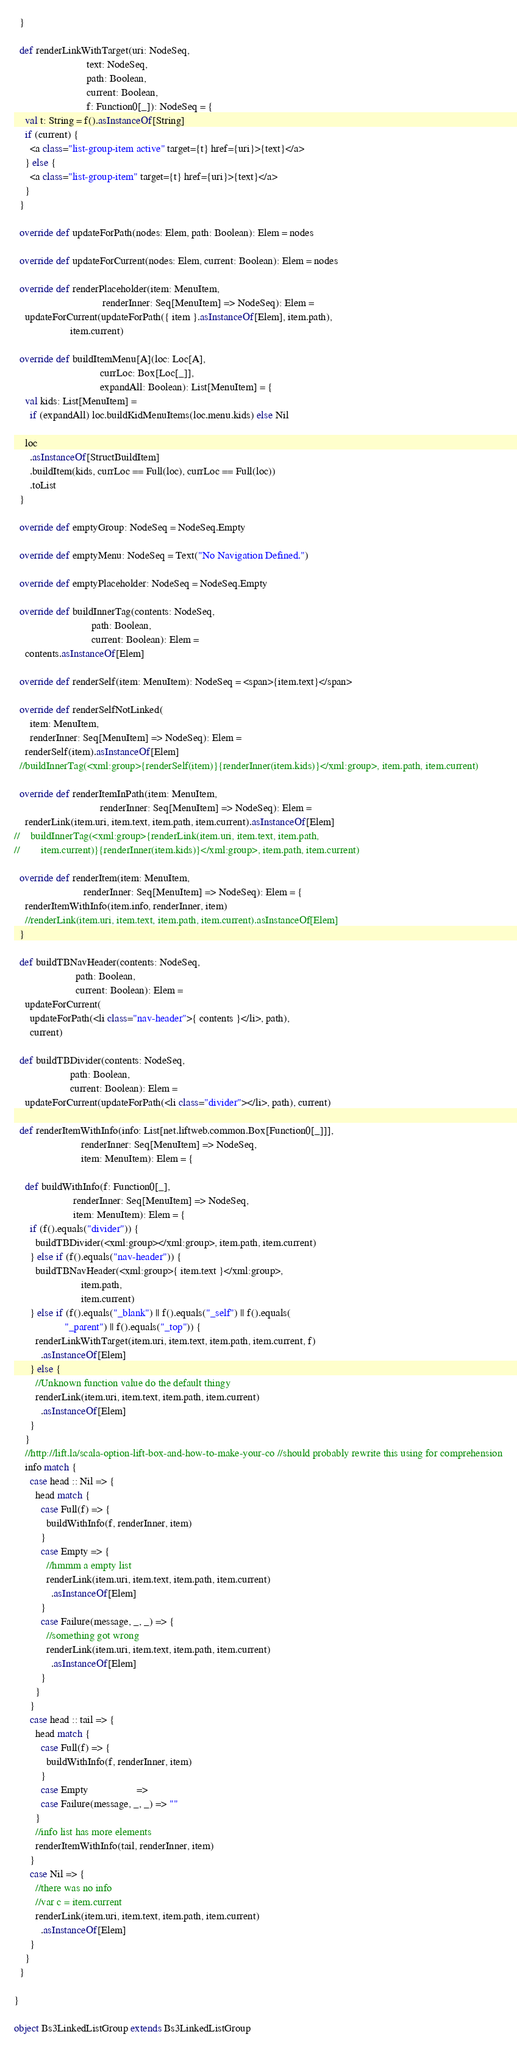<code> <loc_0><loc_0><loc_500><loc_500><_Scala_>  }

  def renderLinkWithTarget(uri: NodeSeq,
                           text: NodeSeq,
                           path: Boolean,
                           current: Boolean,
                           f: Function0[_]): NodeSeq = {
    val t: String = f().asInstanceOf[String]
    if (current) {
      <a class="list-group-item active" target={t} href={uri}>{text}</a>
    } else {
      <a class="list-group-item" target={t} href={uri}>{text}</a>
    }
  }

  override def updateForPath(nodes: Elem, path: Boolean): Elem = nodes

  override def updateForCurrent(nodes: Elem, current: Boolean): Elem = nodes

  override def renderPlaceholder(item: MenuItem,
                                 renderInner: Seq[MenuItem] => NodeSeq): Elem =
    updateForCurrent(updateForPath({ item }.asInstanceOf[Elem], item.path),
                     item.current)

  override def buildItemMenu[A](loc: Loc[A],
                                currLoc: Box[Loc[_]],
                                expandAll: Boolean): List[MenuItem] = {
    val kids: List[MenuItem] =
      if (expandAll) loc.buildKidMenuItems(loc.menu.kids) else Nil

    loc
      .asInstanceOf[StructBuildItem]
      .buildItem(kids, currLoc == Full(loc), currLoc == Full(loc))
      .toList
  }

  override def emptyGroup: NodeSeq = NodeSeq.Empty

  override def emptyMenu: NodeSeq = Text("No Navigation Defined.")

  override def emptyPlaceholder: NodeSeq = NodeSeq.Empty

  override def buildInnerTag(contents: NodeSeq,
                             path: Boolean,
                             current: Boolean): Elem =
    contents.asInstanceOf[Elem]

  override def renderSelf(item: MenuItem): NodeSeq = <span>{item.text}</span>

  override def renderSelfNotLinked(
      item: MenuItem,
      renderInner: Seq[MenuItem] => NodeSeq): Elem =
    renderSelf(item).asInstanceOf[Elem]
  //buildInnerTag(<xml:group>{renderSelf(item)}{renderInner(item.kids)}</xml:group>, item.path, item.current)

  override def renderItemInPath(item: MenuItem,
                                renderInner: Seq[MenuItem] => NodeSeq): Elem =
    renderLink(item.uri, item.text, item.path, item.current).asInstanceOf[Elem]
//    buildInnerTag(<xml:group>{renderLink(item.uri, item.text, item.path,
//        item.current)}{renderInner(item.kids)}</xml:group>, item.path, item.current)

  override def renderItem(item: MenuItem,
                          renderInner: Seq[MenuItem] => NodeSeq): Elem = {
    renderItemWithInfo(item.info, renderInner, item)
    //renderLink(item.uri, item.text, item.path, item.current).asInstanceOf[Elem]
  }

  def buildTBNavHeader(contents: NodeSeq,
                       path: Boolean,
                       current: Boolean): Elem =
    updateForCurrent(
      updateForPath(<li class="nav-header">{ contents }</li>, path),
      current)

  def buildTBDivider(contents: NodeSeq,
                     path: Boolean,
                     current: Boolean): Elem =
    updateForCurrent(updateForPath(<li class="divider"></li>, path), current)

  def renderItemWithInfo(info: List[net.liftweb.common.Box[Function0[_]]],
                         renderInner: Seq[MenuItem] => NodeSeq,
                         item: MenuItem): Elem = {

    def buildWithInfo(f: Function0[_],
                      renderInner: Seq[MenuItem] => NodeSeq,
                      item: MenuItem): Elem = {
      if (f().equals("divider")) {
        buildTBDivider(<xml:group></xml:group>, item.path, item.current)
      } else if (f().equals("nav-header")) {
        buildTBNavHeader(<xml:group>{ item.text }</xml:group>,
                         item.path,
                         item.current)
      } else if (f().equals("_blank") || f().equals("_self") || f().equals(
                   "_parent") || f().equals("_top")) {
        renderLinkWithTarget(item.uri, item.text, item.path, item.current, f)
          .asInstanceOf[Elem]
      } else {
        //Unknown function value do the default thingy
        renderLink(item.uri, item.text, item.path, item.current)
          .asInstanceOf[Elem]
      }
    }
    //http://lift.la/scala-option-lift-box-and-how-to-make-your-co //should probably rewrite this using for comprehension
    info match {
      case head :: Nil => {
        head match {
          case Full(f) => {
            buildWithInfo(f, renderInner, item)
          }
          case Empty => {
            //hmmm a empty list
            renderLink(item.uri, item.text, item.path, item.current)
              .asInstanceOf[Elem]
          }
          case Failure(message, _, _) => {
            //something got wrong
            renderLink(item.uri, item.text, item.path, item.current)
              .asInstanceOf[Elem]
          }
        }
      }
      case head :: tail => {
        head match {
          case Full(f) => {
            buildWithInfo(f, renderInner, item)
          }
          case Empty                  =>
          case Failure(message, _, _) => ""
        }
        //info list has more elements
        renderItemWithInfo(tail, renderInner, item)
      }
      case Nil => {
        //there was no info
        //var c = item.current
        renderLink(item.uri, item.text, item.path, item.current)
          .asInstanceOf[Elem]
      }
    }
  }

}

object Bs3LinkedListGroup extends Bs3LinkedListGroup
</code> 